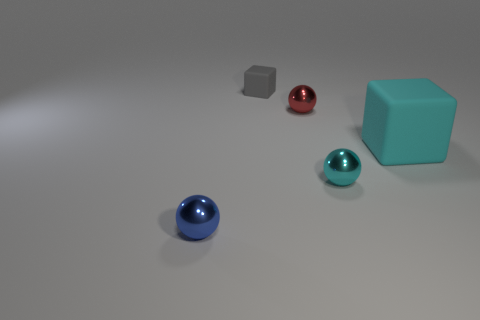Add 5 purple matte cubes. How many objects exist? 10 Subtract all cubes. How many objects are left? 3 Subtract 0 gray balls. How many objects are left? 5 Subtract all big cyan matte blocks. Subtract all small purple metallic spheres. How many objects are left? 4 Add 2 blue objects. How many blue objects are left? 3 Add 2 cubes. How many cubes exist? 4 